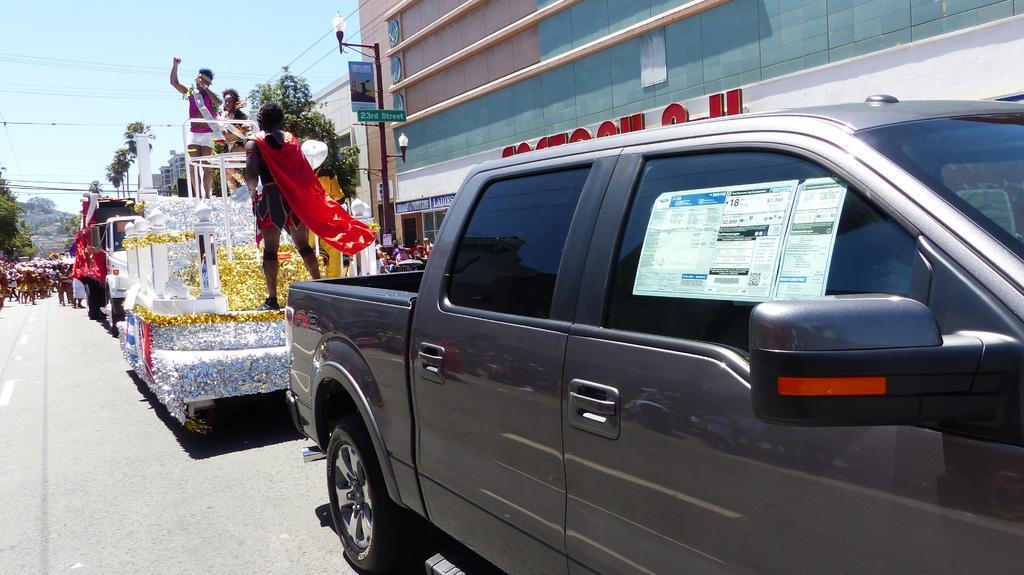Can you describe this image briefly? In this image there are vehicles on the road. Left side there are people on the road. Few people are standing on a vehicle. Few people are on the pavement. There are boards attached to the street light. Background there are buildings and trees. Top of the image there is sky. Right side there is a poster attached to the vehicle. 